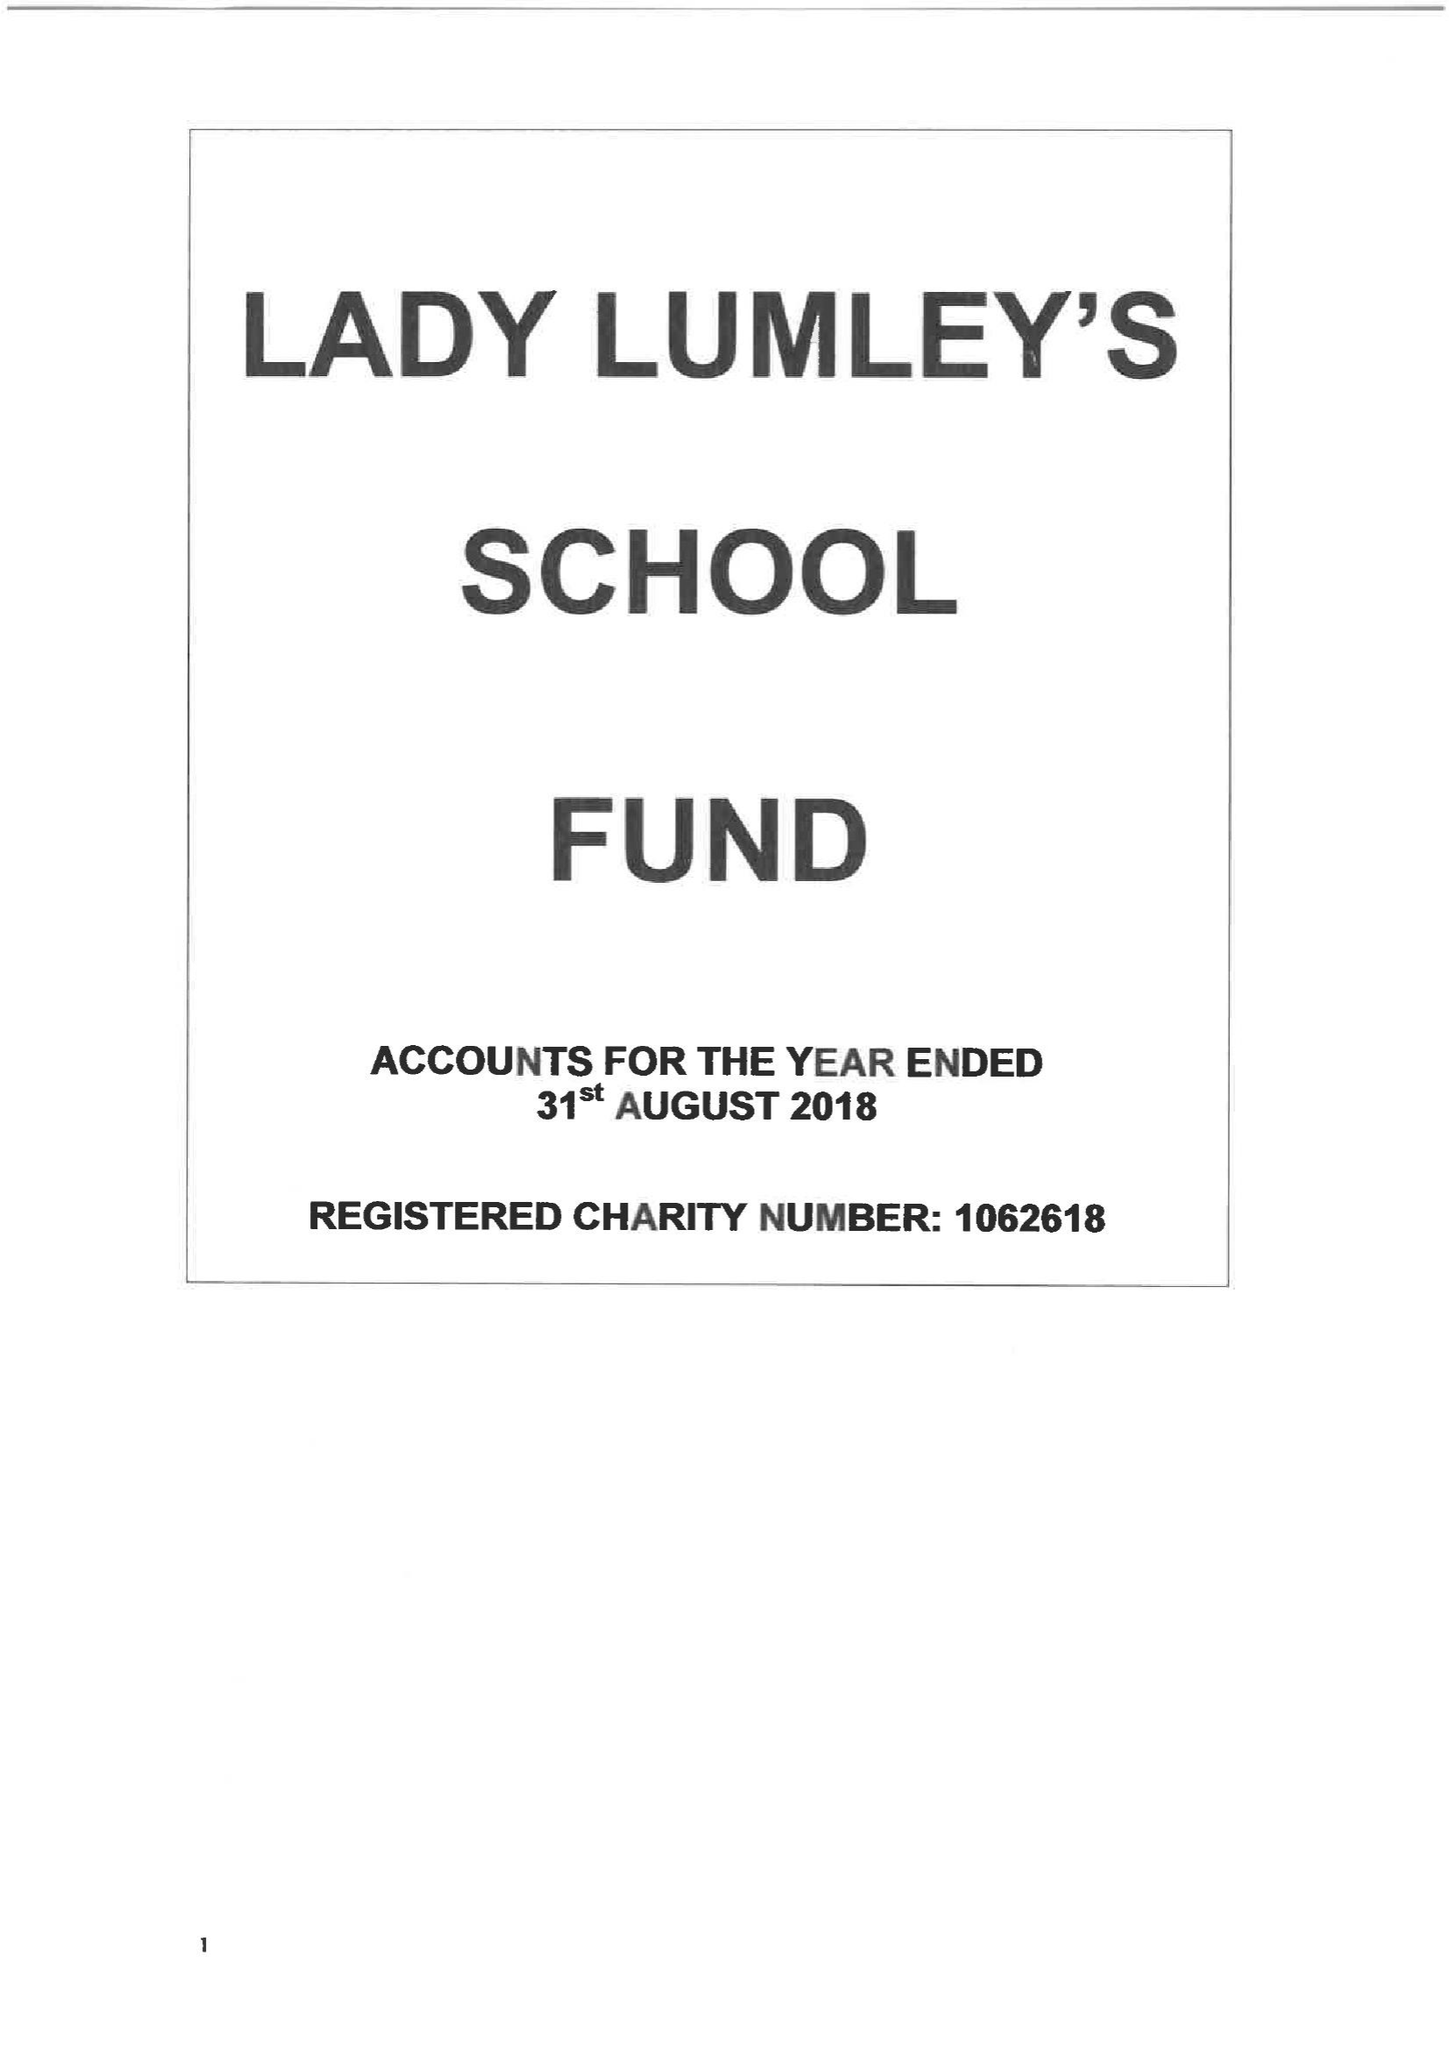What is the value for the address__street_line?
Answer the question using a single word or phrase. SWAINSEA LANE 